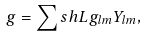<formula> <loc_0><loc_0><loc_500><loc_500>g = \sum s h L g _ { l m } Y _ { l m } ,</formula> 